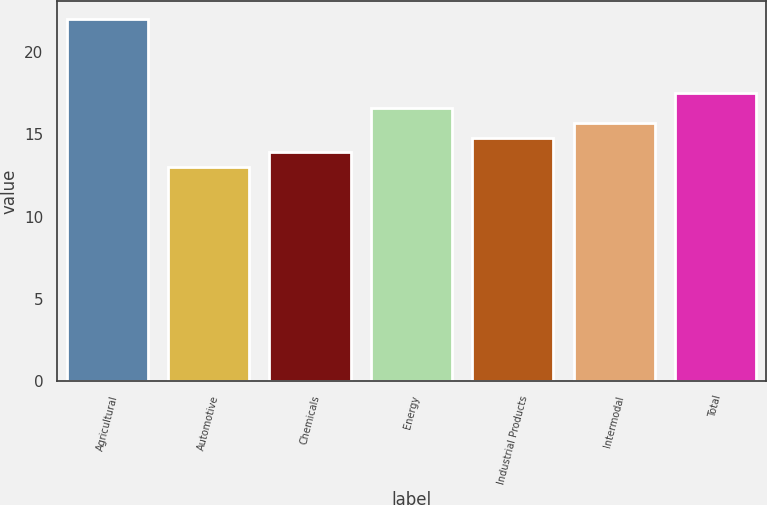<chart> <loc_0><loc_0><loc_500><loc_500><bar_chart><fcel>Agricultural<fcel>Automotive<fcel>Chemicals<fcel>Energy<fcel>Industrial Products<fcel>Intermodal<fcel>Total<nl><fcel>22<fcel>13<fcel>13.9<fcel>16.6<fcel>14.8<fcel>15.7<fcel>17.5<nl></chart> 